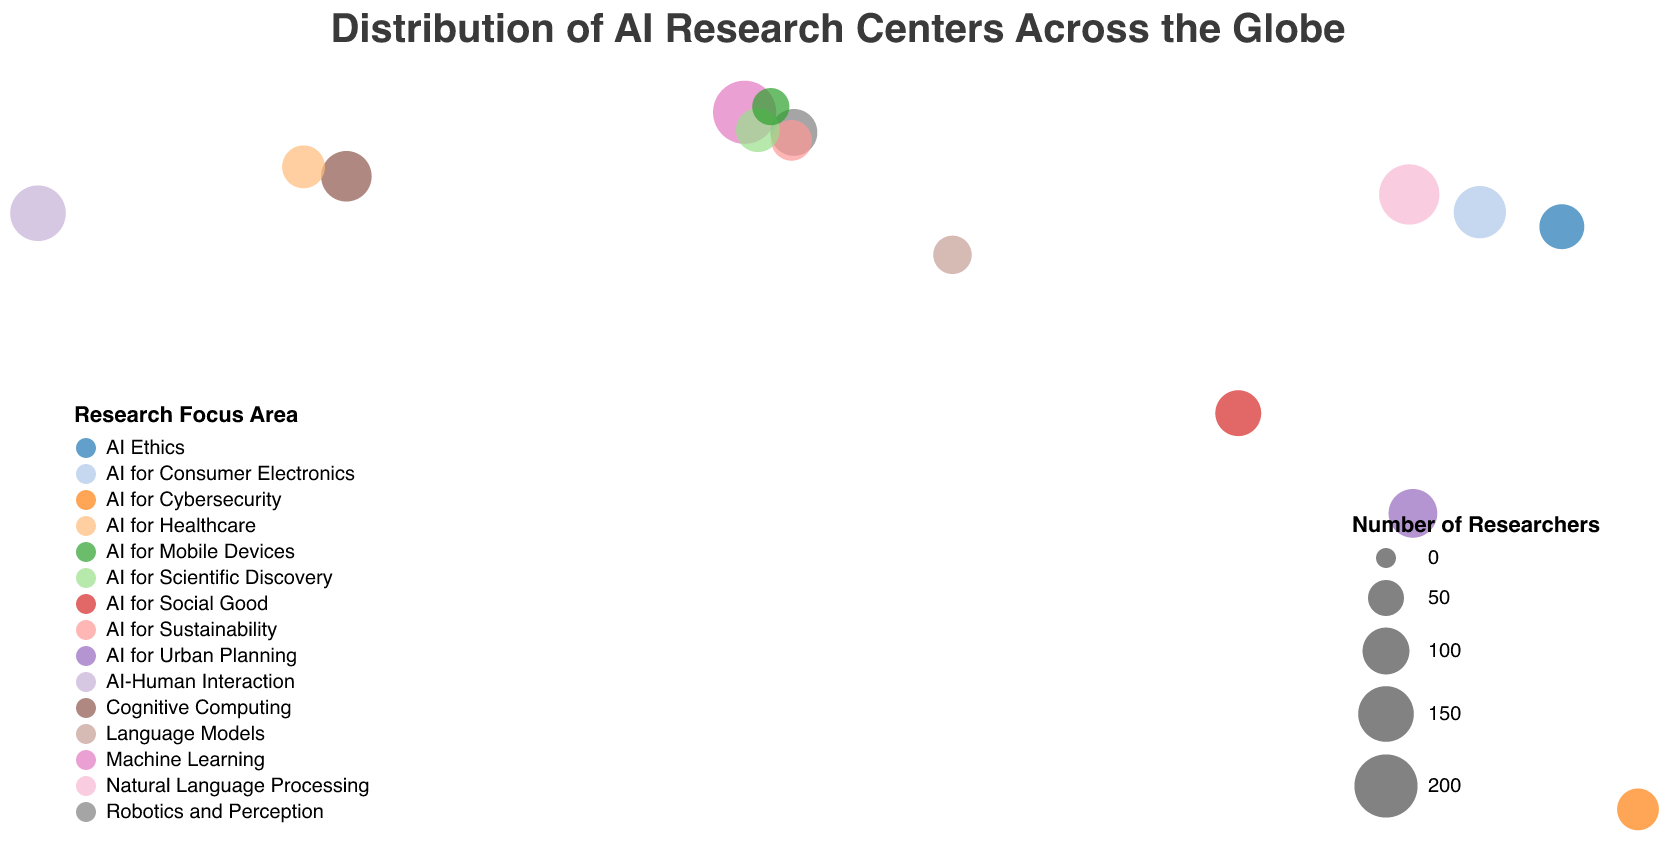What is the title of the figure? The title is usually displayed at the top of the chart and provides a summary of the visualized data. The title in this case is "Distribution of AI Research Centers Across the Globe".
Answer: Distribution of AI Research Centers Across the Globe Which city has the largest number of researchers? To find this, look at all the circles on the map and identify the one with the largest size, then check the tooltip or legend for the exact number of researchers and corresponding city. The circle with the largest size corresponds to London.
Answer: London How many AI research centers are there in the USA? Locate all the data points within the USA on the map. There are two data points, one in Stanford and another in Boston, indicating two research centers.
Answer: 2 What's the most common focus area among the listed research centers? Look at the legend on the bottom-left, which shows the color representation of each focus area, and count the occurrences of each focus area based on the circles' colors. "AI-Human Interaction" appears only once, while other areas like "AI for Healthcare", "AI for Social Good", and so on might appear more often based on the encoded data. The specific count would indicate the most common focus area.
Answer: No single most common area due to diverse focus areas Compare the number of researchers between DeepMind in London and Microsoft Research Asia in Beijing. Refer to the tooltips or legends for specific researcher counts. DeepMind in London has 200 researchers, and Microsoft Research Asia in Beijing has 180 researchers. Compare these two numbers directly.
Answer: DeepMind (200) > Microsoft Research Asia (180) What is the combined total number of researchers in Asia (Beijing, Tokyo, Seoul, Singapore)? Identify the researcher numbers in each city from the map: Beijing (180), Tokyo (90), Seoul (130), and Singapore (110). Add the numbers together: 180 + 90 + 130 + 110.
Answer: 510 Which research center focuses on AI for Urban Planning? Look at the tooltips or legend associated with each circle, from the dataset it is indicated that AI Singapore in Singapore focuses on AI for Urban Planning.
Answer: AI Singapore Are there more AI researchers in North America or Europe? Identify the researchers in North America (Stanford: 150, Boston: 120, Toronto: 80) and Europe (London: 200, Tübingen: 100, Zürich: 70, Paris: 85, Amsterdam: 55). Sum the number of researchers in each region and compare: North America has 150 + 120 + 80 = 350 and Europe has 200 + 100 + 70 + 85 + 55 = 510.
Answer: Europe (510) > North America (350) 